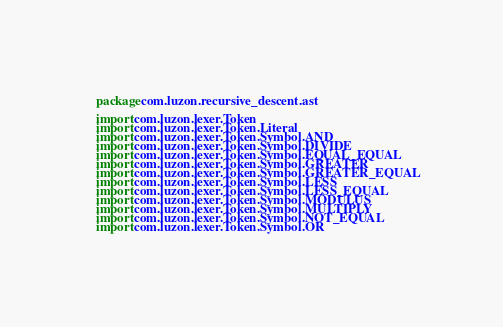<code> <loc_0><loc_0><loc_500><loc_500><_Kotlin_>package com.luzon.recursive_descent.ast

import com.luzon.lexer.Token
import com.luzon.lexer.Token.Literal
import com.luzon.lexer.Token.Symbol.AND
import com.luzon.lexer.Token.Symbol.DIVIDE
import com.luzon.lexer.Token.Symbol.EQUAL_EQUAL
import com.luzon.lexer.Token.Symbol.GREATER
import com.luzon.lexer.Token.Symbol.GREATER_EQUAL
import com.luzon.lexer.Token.Symbol.LESS
import com.luzon.lexer.Token.Symbol.LESS_EQUAL
import com.luzon.lexer.Token.Symbol.MODULUS
import com.luzon.lexer.Token.Symbol.MULTIPLY
import com.luzon.lexer.Token.Symbol.NOT_EQUAL
import com.luzon.lexer.Token.Symbol.OR</code> 